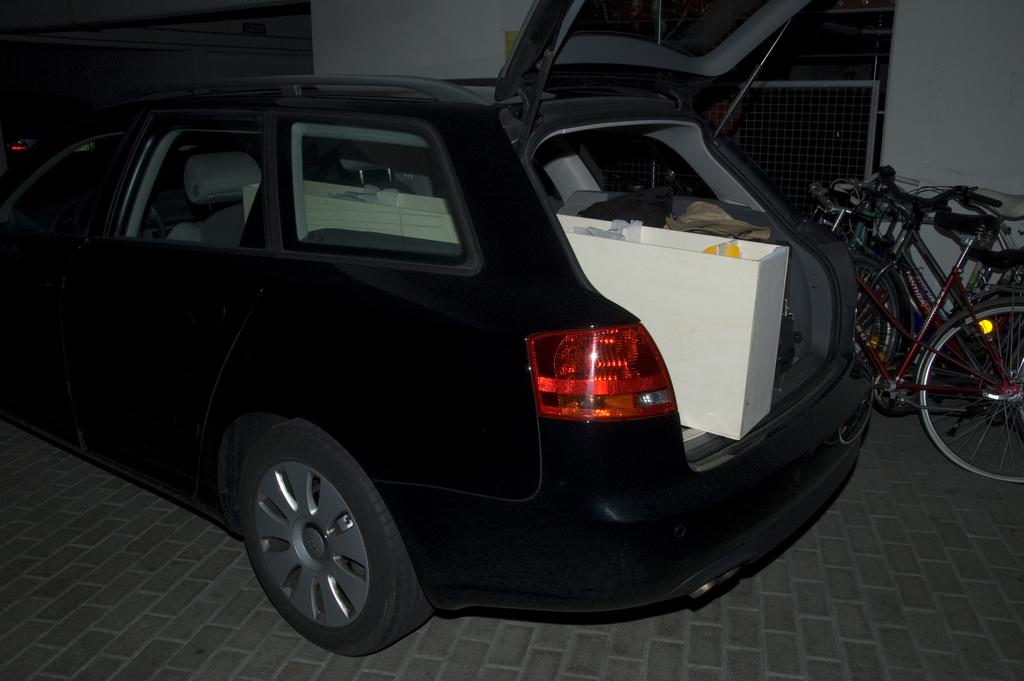What is the main subject of the image? The main subject of the image is a car. Are there any objects or items inside the car? Yes, there are items inside the car. What can be seen behind the car on the right side? There are bicycles behind the car on the right side. Can you describe the background of the image? There is a wall with mesh in the background of the image. What is the weight of the air inside the car? The weight of the air inside the car cannot be determined from the image, as it is not possible to measure the weight of air in this context. 